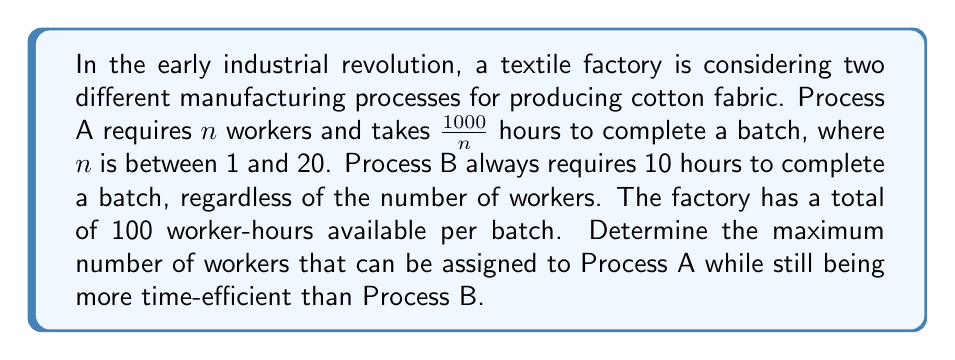Help me with this question. To solve this problem, we need to follow these steps:

1) First, let's express the time taken by Process A as a function of n:
   $$T_A(n) = \frac{1000}{n}$$

2) We know that Process B always takes 10 hours, so:
   $$T_B = 10$$

3) We want to find the maximum n for which Process A is more efficient than Process B:
   $$T_A(n) < T_B$$
   $$\frac{1000}{n} < 10$$

4) Solving this inequality:
   $$1000 < 10n$$
   $$100 < n$$

5) However, we also need to consider the constraint of 100 worker-hours per batch:
   $$n \cdot T_A(n) \leq 100$$
   $$n \cdot \frac{1000}{n} \leq 100$$
   $$1000 \leq 100$$

   This inequality is always true, so this constraint doesn't affect our solution.

6) Finally, we need to consider that n is between 1 and 20 according to the question.

Therefore, the maximum value of n that satisfies all conditions is 20.
Answer: The maximum number of workers that can be assigned to Process A while still being more time-efficient than Process B is 20. 